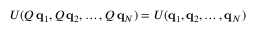<formula> <loc_0><loc_0><loc_500><loc_500>U ( Q \, q _ { 1 } , Q \, q _ { 2 } , \dots , Q \, q _ { N } ) = U ( q _ { 1 } , q _ { 2 } , \dots , q _ { N } )</formula> 